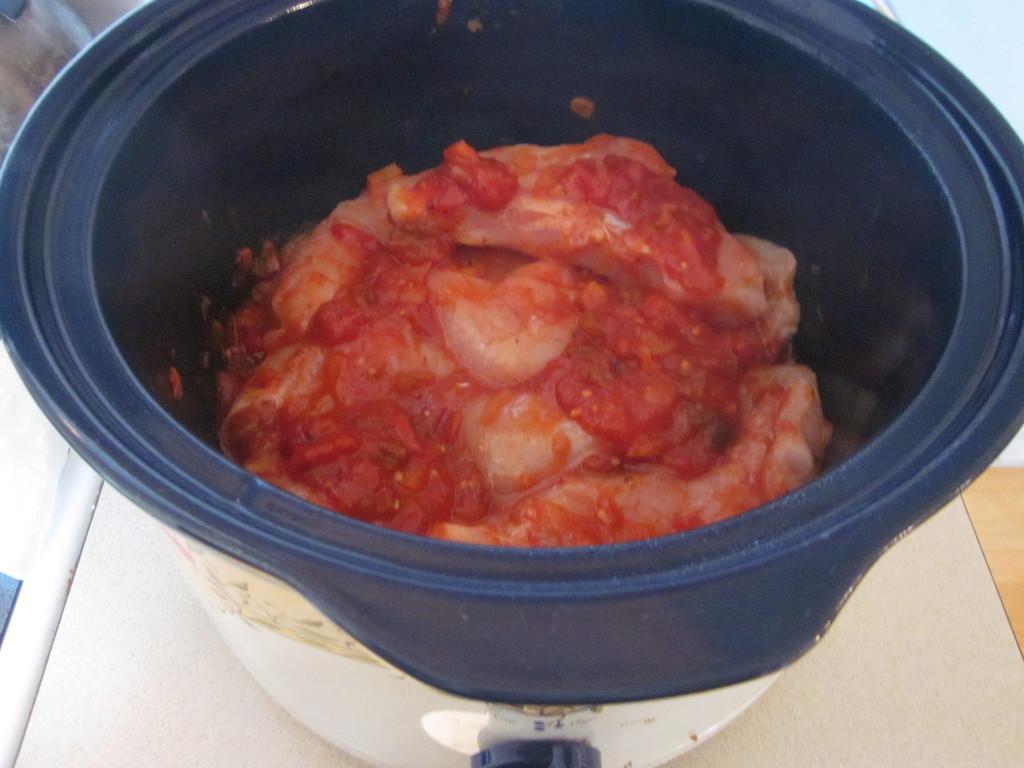Could you give a brief overview of what you see in this image? In the image we can see a container. In the container there is a food item. 